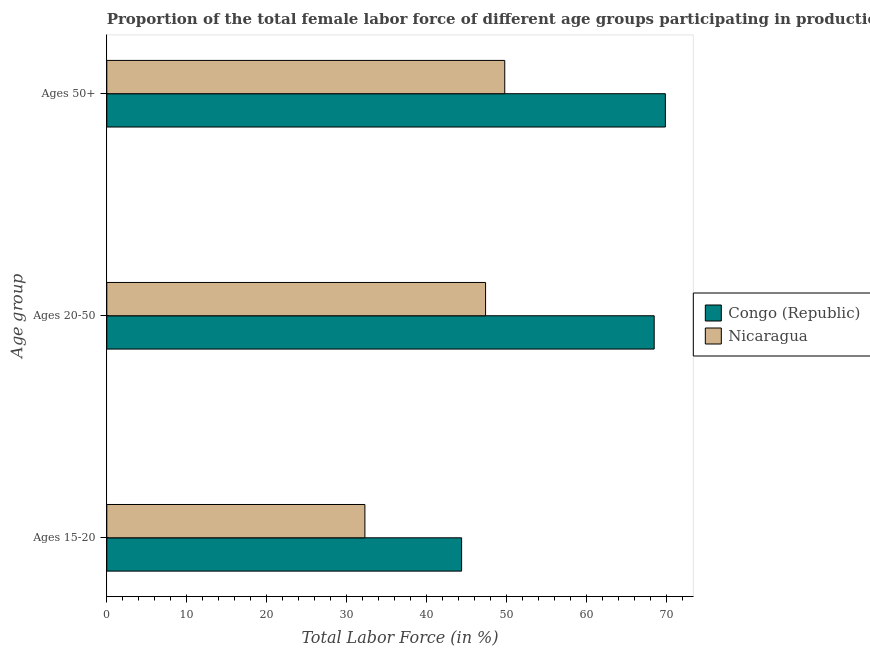Are the number of bars per tick equal to the number of legend labels?
Ensure brevity in your answer.  Yes. Are the number of bars on each tick of the Y-axis equal?
Provide a succinct answer. Yes. How many bars are there on the 2nd tick from the bottom?
Give a very brief answer. 2. What is the label of the 1st group of bars from the top?
Make the answer very short. Ages 50+. What is the percentage of female labor force above age 50 in Nicaragua?
Your answer should be compact. 49.8. Across all countries, what is the maximum percentage of female labor force within the age group 20-50?
Keep it short and to the point. 68.5. Across all countries, what is the minimum percentage of female labor force within the age group 15-20?
Provide a short and direct response. 32.3. In which country was the percentage of female labor force within the age group 15-20 maximum?
Your answer should be very brief. Congo (Republic). In which country was the percentage of female labor force within the age group 20-50 minimum?
Ensure brevity in your answer.  Nicaragua. What is the total percentage of female labor force within the age group 15-20 in the graph?
Offer a terse response. 76.7. What is the difference between the percentage of female labor force within the age group 20-50 in Nicaragua and that in Congo (Republic)?
Provide a succinct answer. -21.1. What is the difference between the percentage of female labor force above age 50 in Congo (Republic) and the percentage of female labor force within the age group 15-20 in Nicaragua?
Keep it short and to the point. 37.6. What is the average percentage of female labor force within the age group 15-20 per country?
Make the answer very short. 38.35. What is the difference between the percentage of female labor force within the age group 15-20 and percentage of female labor force above age 50 in Nicaragua?
Give a very brief answer. -17.5. What is the ratio of the percentage of female labor force above age 50 in Nicaragua to that in Congo (Republic)?
Keep it short and to the point. 0.71. Is the difference between the percentage of female labor force within the age group 15-20 in Congo (Republic) and Nicaragua greater than the difference between the percentage of female labor force within the age group 20-50 in Congo (Republic) and Nicaragua?
Provide a succinct answer. No. What is the difference between the highest and the second highest percentage of female labor force above age 50?
Keep it short and to the point. 20.1. What is the difference between the highest and the lowest percentage of female labor force within the age group 15-20?
Keep it short and to the point. 12.1. What does the 1st bar from the top in Ages 50+ represents?
Your response must be concise. Nicaragua. What does the 2nd bar from the bottom in Ages 20-50 represents?
Offer a terse response. Nicaragua. Are all the bars in the graph horizontal?
Provide a short and direct response. Yes. How many countries are there in the graph?
Your response must be concise. 2. Where does the legend appear in the graph?
Ensure brevity in your answer.  Center right. What is the title of the graph?
Provide a short and direct response. Proportion of the total female labor force of different age groups participating in production in 2013. Does "Puerto Rico" appear as one of the legend labels in the graph?
Provide a succinct answer. No. What is the label or title of the X-axis?
Offer a very short reply. Total Labor Force (in %). What is the label or title of the Y-axis?
Provide a succinct answer. Age group. What is the Total Labor Force (in %) in Congo (Republic) in Ages 15-20?
Offer a very short reply. 44.4. What is the Total Labor Force (in %) of Nicaragua in Ages 15-20?
Offer a very short reply. 32.3. What is the Total Labor Force (in %) of Congo (Republic) in Ages 20-50?
Provide a short and direct response. 68.5. What is the Total Labor Force (in %) of Nicaragua in Ages 20-50?
Keep it short and to the point. 47.4. What is the Total Labor Force (in %) of Congo (Republic) in Ages 50+?
Make the answer very short. 69.9. What is the Total Labor Force (in %) in Nicaragua in Ages 50+?
Give a very brief answer. 49.8. Across all Age group, what is the maximum Total Labor Force (in %) in Congo (Republic)?
Make the answer very short. 69.9. Across all Age group, what is the maximum Total Labor Force (in %) of Nicaragua?
Ensure brevity in your answer.  49.8. Across all Age group, what is the minimum Total Labor Force (in %) in Congo (Republic)?
Give a very brief answer. 44.4. Across all Age group, what is the minimum Total Labor Force (in %) in Nicaragua?
Your answer should be compact. 32.3. What is the total Total Labor Force (in %) of Congo (Republic) in the graph?
Provide a short and direct response. 182.8. What is the total Total Labor Force (in %) in Nicaragua in the graph?
Provide a succinct answer. 129.5. What is the difference between the Total Labor Force (in %) of Congo (Republic) in Ages 15-20 and that in Ages 20-50?
Your answer should be compact. -24.1. What is the difference between the Total Labor Force (in %) in Nicaragua in Ages 15-20 and that in Ages 20-50?
Your response must be concise. -15.1. What is the difference between the Total Labor Force (in %) in Congo (Republic) in Ages 15-20 and that in Ages 50+?
Provide a succinct answer. -25.5. What is the difference between the Total Labor Force (in %) in Nicaragua in Ages 15-20 and that in Ages 50+?
Provide a succinct answer. -17.5. What is the difference between the Total Labor Force (in %) of Congo (Republic) in Ages 20-50 and that in Ages 50+?
Your response must be concise. -1.4. What is the difference between the Total Labor Force (in %) in Congo (Republic) in Ages 20-50 and the Total Labor Force (in %) in Nicaragua in Ages 50+?
Give a very brief answer. 18.7. What is the average Total Labor Force (in %) of Congo (Republic) per Age group?
Make the answer very short. 60.93. What is the average Total Labor Force (in %) in Nicaragua per Age group?
Provide a short and direct response. 43.17. What is the difference between the Total Labor Force (in %) in Congo (Republic) and Total Labor Force (in %) in Nicaragua in Ages 20-50?
Your answer should be compact. 21.1. What is the difference between the Total Labor Force (in %) in Congo (Republic) and Total Labor Force (in %) in Nicaragua in Ages 50+?
Ensure brevity in your answer.  20.1. What is the ratio of the Total Labor Force (in %) of Congo (Republic) in Ages 15-20 to that in Ages 20-50?
Your answer should be very brief. 0.65. What is the ratio of the Total Labor Force (in %) in Nicaragua in Ages 15-20 to that in Ages 20-50?
Make the answer very short. 0.68. What is the ratio of the Total Labor Force (in %) in Congo (Republic) in Ages 15-20 to that in Ages 50+?
Your response must be concise. 0.64. What is the ratio of the Total Labor Force (in %) in Nicaragua in Ages 15-20 to that in Ages 50+?
Your response must be concise. 0.65. What is the ratio of the Total Labor Force (in %) in Congo (Republic) in Ages 20-50 to that in Ages 50+?
Ensure brevity in your answer.  0.98. What is the ratio of the Total Labor Force (in %) of Nicaragua in Ages 20-50 to that in Ages 50+?
Your response must be concise. 0.95. What is the difference between the highest and the second highest Total Labor Force (in %) of Nicaragua?
Offer a very short reply. 2.4. What is the difference between the highest and the lowest Total Labor Force (in %) in Congo (Republic)?
Ensure brevity in your answer.  25.5. 